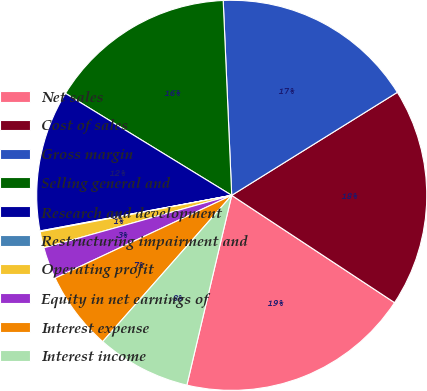<chart> <loc_0><loc_0><loc_500><loc_500><pie_chart><fcel>Net sales<fcel>Cost of sales<fcel>Gross margin<fcel>Selling general and<fcel>Research and development<fcel>Restructuring impairment and<fcel>Operating profit<fcel>Equity in net earnings of<fcel>Interest expense<fcel>Interest income<nl><fcel>19.42%<fcel>18.13%<fcel>16.84%<fcel>15.55%<fcel>11.68%<fcel>0.06%<fcel>1.35%<fcel>2.64%<fcel>6.52%<fcel>7.81%<nl></chart> 